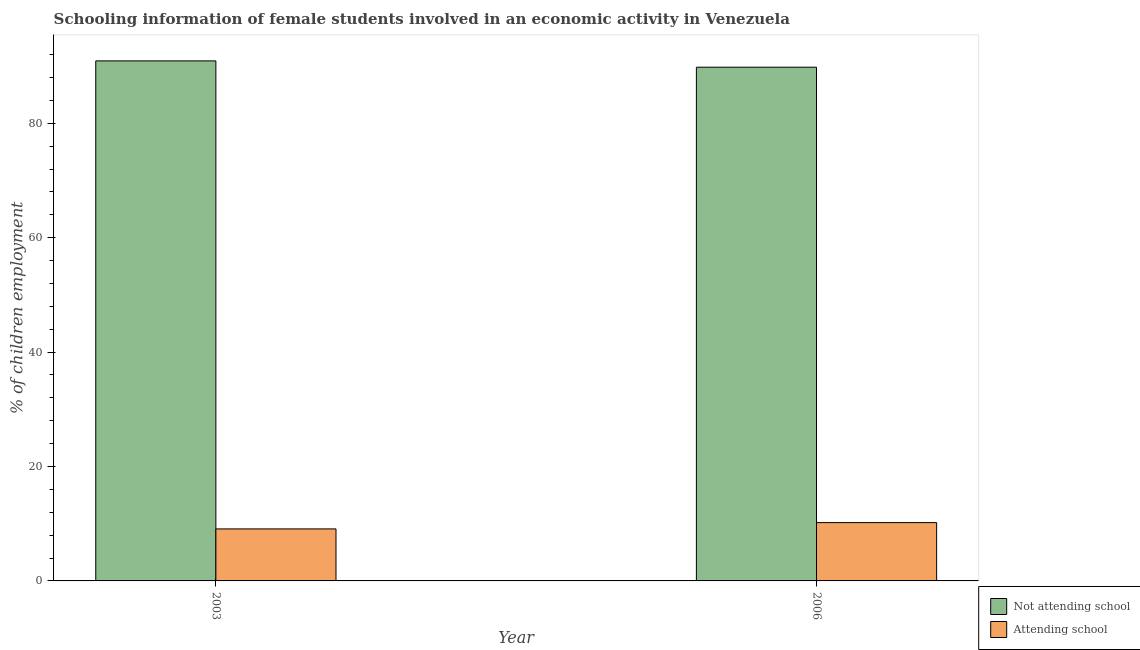How many different coloured bars are there?
Provide a short and direct response. 2. Are the number of bars on each tick of the X-axis equal?
Keep it short and to the point. Yes. How many bars are there on the 1st tick from the left?
Provide a succinct answer. 2. What is the percentage of employed females who are attending school in 2003?
Provide a succinct answer. 9.09. Across all years, what is the maximum percentage of employed females who are attending school?
Ensure brevity in your answer.  10.19. Across all years, what is the minimum percentage of employed females who are attending school?
Keep it short and to the point. 9.09. In which year was the percentage of employed females who are attending school maximum?
Your response must be concise. 2006. What is the total percentage of employed females who are not attending school in the graph?
Give a very brief answer. 180.72. What is the difference between the percentage of employed females who are not attending school in 2003 and that in 2006?
Make the answer very short. 1.1. What is the difference between the percentage of employed females who are not attending school in 2006 and the percentage of employed females who are attending school in 2003?
Provide a short and direct response. -1.1. What is the average percentage of employed females who are not attending school per year?
Offer a very short reply. 90.36. In the year 2003, what is the difference between the percentage of employed females who are attending school and percentage of employed females who are not attending school?
Provide a succinct answer. 0. In how many years, is the percentage of employed females who are attending school greater than 4 %?
Your answer should be very brief. 2. What is the ratio of the percentage of employed females who are attending school in 2003 to that in 2006?
Provide a short and direct response. 0.89. What does the 1st bar from the left in 2003 represents?
Provide a short and direct response. Not attending school. What does the 1st bar from the right in 2006 represents?
Offer a terse response. Attending school. How many bars are there?
Make the answer very short. 4. Are all the bars in the graph horizontal?
Give a very brief answer. No. How many years are there in the graph?
Make the answer very short. 2. Are the values on the major ticks of Y-axis written in scientific E-notation?
Your response must be concise. No. Does the graph contain any zero values?
Give a very brief answer. No. How many legend labels are there?
Ensure brevity in your answer.  2. What is the title of the graph?
Your answer should be very brief. Schooling information of female students involved in an economic activity in Venezuela. Does "Study and work" appear as one of the legend labels in the graph?
Make the answer very short. No. What is the label or title of the Y-axis?
Your response must be concise. % of children employment. What is the % of children employment of Not attending school in 2003?
Your answer should be compact. 90.91. What is the % of children employment in Attending school in 2003?
Make the answer very short. 9.09. What is the % of children employment in Not attending school in 2006?
Keep it short and to the point. 89.81. What is the % of children employment of Attending school in 2006?
Provide a succinct answer. 10.19. Across all years, what is the maximum % of children employment of Not attending school?
Keep it short and to the point. 90.91. Across all years, what is the maximum % of children employment in Attending school?
Your answer should be very brief. 10.19. Across all years, what is the minimum % of children employment of Not attending school?
Keep it short and to the point. 89.81. Across all years, what is the minimum % of children employment in Attending school?
Keep it short and to the point. 9.09. What is the total % of children employment of Not attending school in the graph?
Ensure brevity in your answer.  180.72. What is the total % of children employment in Attending school in the graph?
Offer a terse response. 19.29. What is the difference between the % of children employment in Not attending school in 2003 and that in 2006?
Keep it short and to the point. 1.1. What is the difference between the % of children employment in Attending school in 2003 and that in 2006?
Ensure brevity in your answer.  -1.1. What is the difference between the % of children employment in Not attending school in 2003 and the % of children employment in Attending school in 2006?
Make the answer very short. 80.72. What is the average % of children employment in Not attending school per year?
Your response must be concise. 90.36. What is the average % of children employment of Attending school per year?
Your answer should be compact. 9.64. In the year 2003, what is the difference between the % of children employment of Not attending school and % of children employment of Attending school?
Your answer should be compact. 81.82. In the year 2006, what is the difference between the % of children employment of Not attending school and % of children employment of Attending school?
Provide a short and direct response. 79.61. What is the ratio of the % of children employment in Not attending school in 2003 to that in 2006?
Your response must be concise. 1.01. What is the ratio of the % of children employment in Attending school in 2003 to that in 2006?
Your answer should be very brief. 0.89. What is the difference between the highest and the second highest % of children employment in Not attending school?
Provide a short and direct response. 1.1. What is the difference between the highest and the second highest % of children employment in Attending school?
Your answer should be very brief. 1.1. What is the difference between the highest and the lowest % of children employment of Not attending school?
Offer a very short reply. 1.1. What is the difference between the highest and the lowest % of children employment in Attending school?
Your response must be concise. 1.1. 